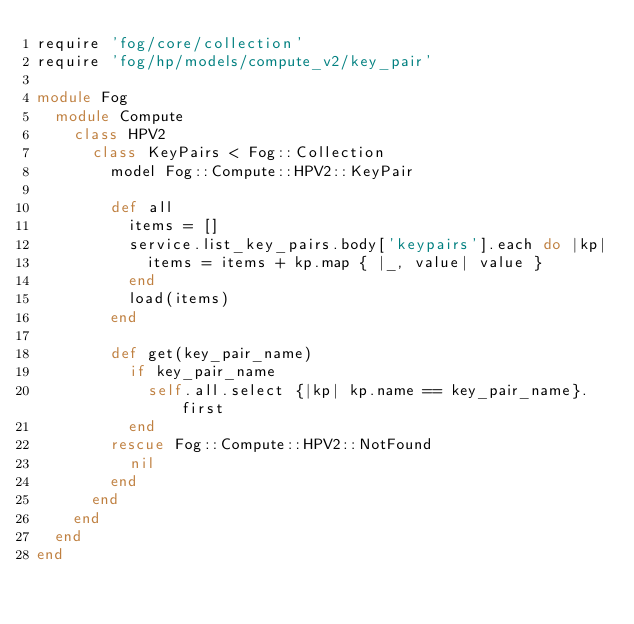<code> <loc_0><loc_0><loc_500><loc_500><_Ruby_>require 'fog/core/collection'
require 'fog/hp/models/compute_v2/key_pair'

module Fog
  module Compute
    class HPV2
      class KeyPairs < Fog::Collection
        model Fog::Compute::HPV2::KeyPair

        def all
          items = []
          service.list_key_pairs.body['keypairs'].each do |kp|
            items = items + kp.map { |_, value| value }
          end
          load(items)
        end

        def get(key_pair_name)
          if key_pair_name
            self.all.select {|kp| kp.name == key_pair_name}.first
          end
        rescue Fog::Compute::HPV2::NotFound
          nil
        end
      end
    end
  end
end
</code> 